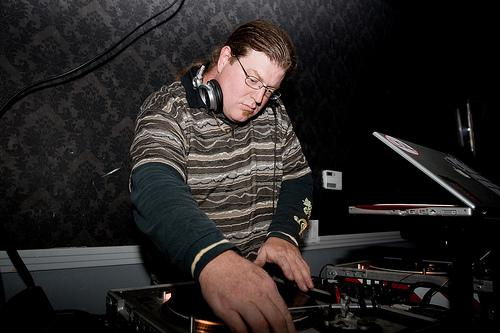Question: how many photos were taken?
Choices:
A. 5.
B. 25.
C. 15.
D. 10.
Answer with the letter. Answer: D Question: who is this photo of?
Choices:
A. A bride.
B. A clerk.
C. A DJ.
D. A politician.
Answer with the letter. Answer: C Question: where was this scene taken?
Choices:
A. At a park.
B. At a baseball game.
C. At a fair.
D. At a disco.
Answer with the letter. Answer: D Question: why was this photo taken?
Choices:
A. For a scrapbook.
B. For memories.
C. For a souvenir.
D. For a collage.
Answer with the letter. Answer: C 